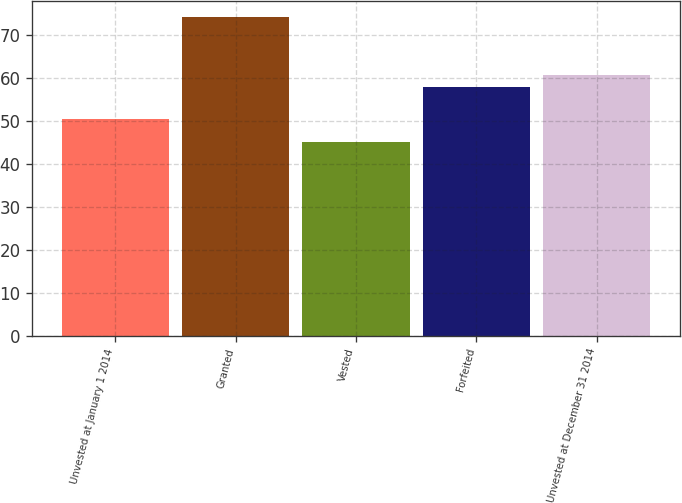Convert chart to OTSL. <chart><loc_0><loc_0><loc_500><loc_500><bar_chart><fcel>Unvested at January 1 2014<fcel>Granted<fcel>Vested<fcel>Forfeited<fcel>Unvested at December 31 2014<nl><fcel>50.33<fcel>74.1<fcel>45.1<fcel>57.83<fcel>60.73<nl></chart> 